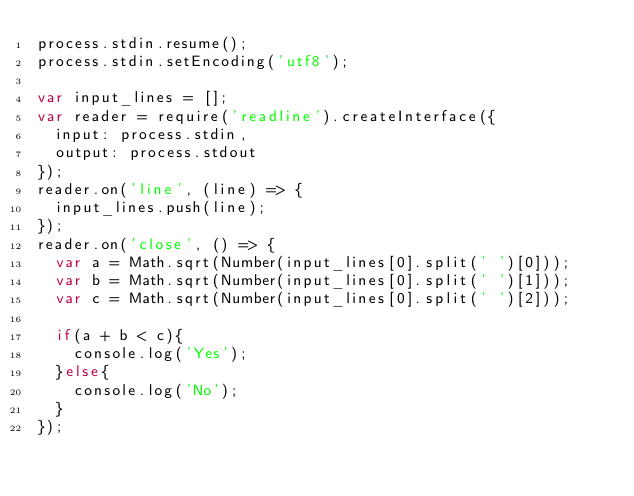<code> <loc_0><loc_0><loc_500><loc_500><_JavaScript_>process.stdin.resume();
process.stdin.setEncoding('utf8');

var input_lines = []; 
var reader = require('readline').createInterface({
  input: process.stdin,
  output: process.stdout
});
reader.on('line', (line) => {
  input_lines.push(line);
});
reader.on('close', () => {
  var a = Math.sqrt(Number(input_lines[0].split(' ')[0]));
  var b = Math.sqrt(Number(input_lines[0].split(' ')[1]));
  var c = Math.sqrt(Number(input_lines[0].split(' ')[2]));

  if(a + b < c){
    console.log('Yes');
  }else{
    console.log('No');
  }
});</code> 